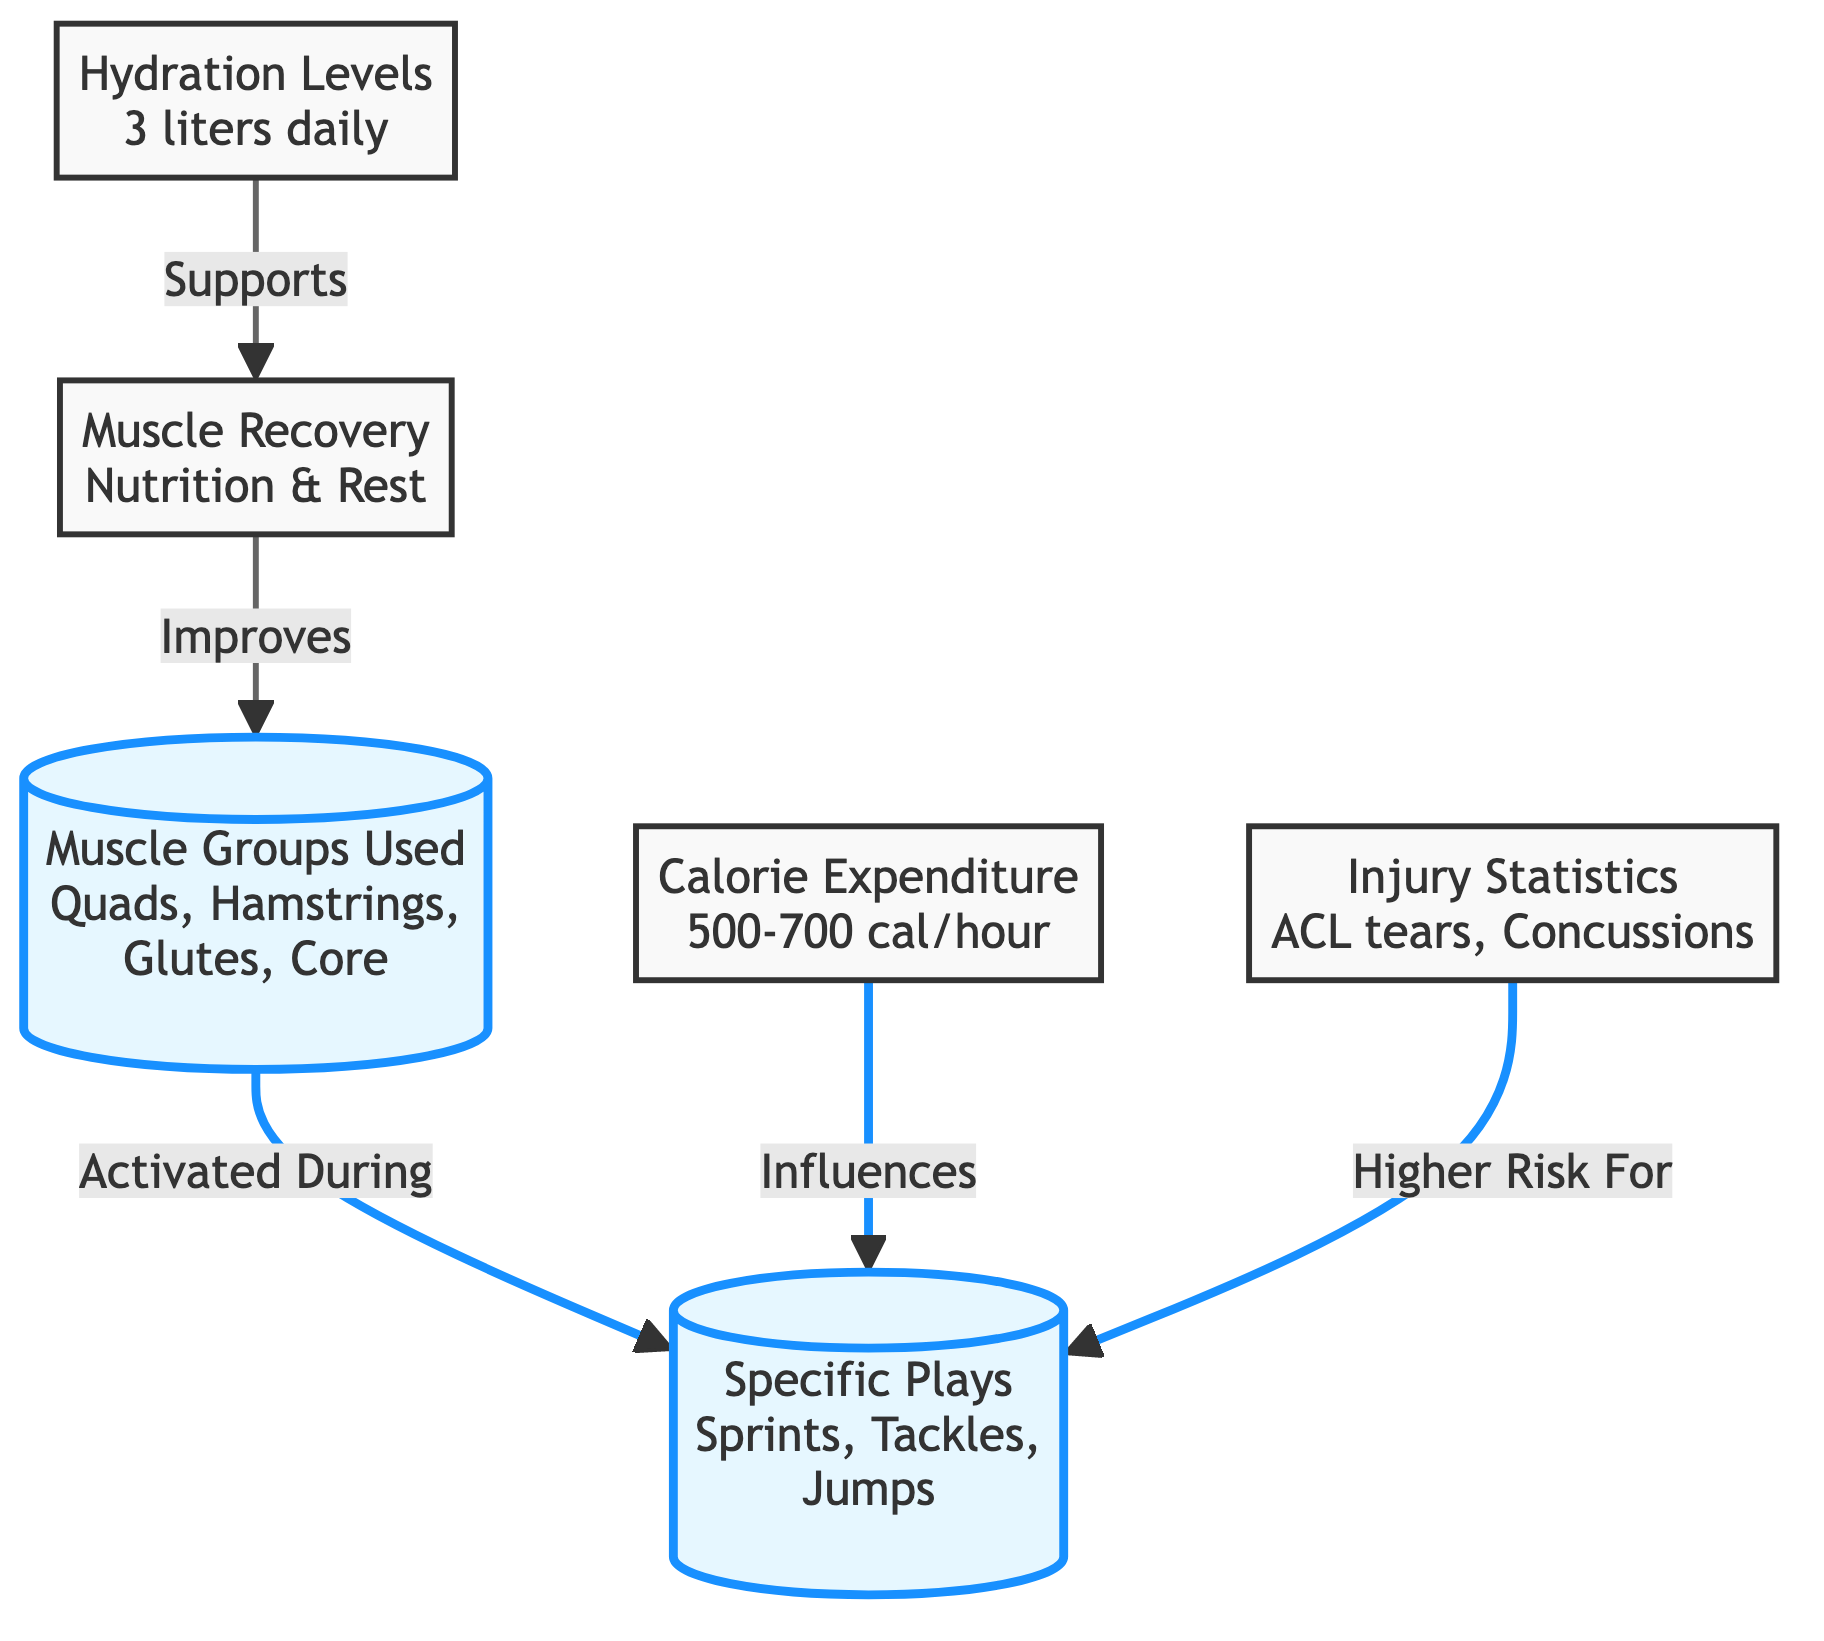What muscle groups are used during specific plays? The diagram shows that the muscle groups used during specific plays include Quads, Hamstrings, Glutes, and Core. These are directly connected to the "Specific Plays" node.
Answer: Quads, Hamstrings, Glutes, Core What is the calorie expenditure range for football players? According to the diagram, the calorie expenditure for football players is indicated to be between 500-700 calories per hour. This information is specifically labeled under the "Calorie Expenditure" node.
Answer: 500-700 cal/hour What supports muscle recovery? The diagram connects hydration levels to muscle recovery, indicating that hydration levels support muscle recovery. This is a direct relationship shown in the flowchart.
Answer: Hydration Levels What is one of the specific plays listed in the diagram? The diagram highlights "Sprints," "Tackles," and "Jumps" under the "Specific Plays" node, indicating these are examples of plays that engage the highlighted muscle groups.
Answer: Sprints Which injury has a higher risk during specific plays? The diagram states that ACL tears and Concussions are indicated under "Injury Statistics," showing these injuries have a higher risk during specific plays. Since ACL tears are more commonly associated with sports involving sudden stopping or pivoting, they directly link to the specific plays.
Answer: ACL tears How many muscle groups are identified in the diagram? The diagram lists four distinct muscle groups used: Quads, Hamstrings, Glutes, and Core. This is evident from the "Muscle Groups Used" node which distinctly identifies them.
Answer: 4 How do muscle recovery practices improve muscle groups? The flowchart illustrates that muscle recovery, which involves nutrition and rest, leads to an improvement in muscle groups. The connection is shown between "Muscle Recovery" and "Muscle Groups Used" indicating a flow of benefit to muscle performance.
Answer: Improves What is the daily recommended hydration level for football players? The diagram specifies that hydration levels should be 3 liters daily. This figure is directly presented under the "Hydration Levels" node, indicating the recommendation for maintaining adequate hydration.
Answer: 3 liters daily 